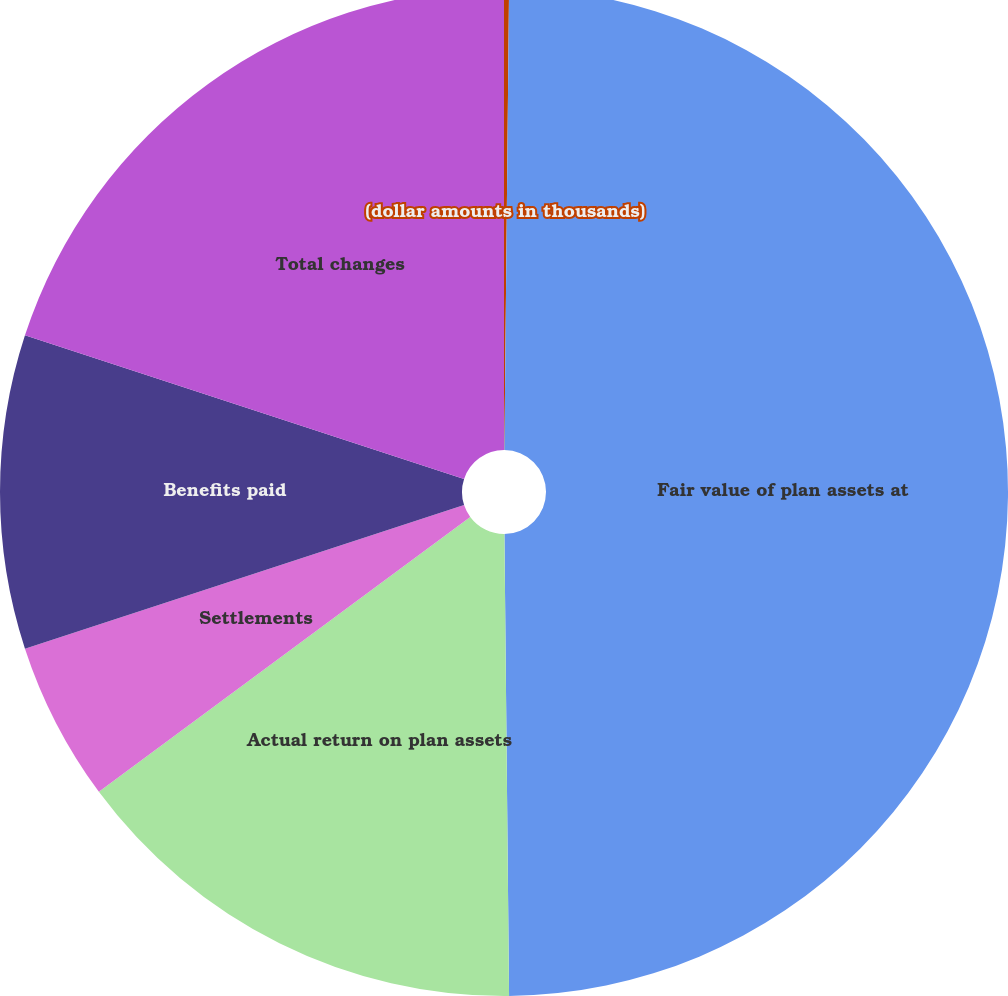Convert chart to OTSL. <chart><loc_0><loc_0><loc_500><loc_500><pie_chart><fcel>(dollar amounts in thousands)<fcel>Fair value of plan assets at<fcel>Actual return on plan assets<fcel>Settlements<fcel>Benefits paid<fcel>Total changes<nl><fcel>0.16%<fcel>49.68%<fcel>15.02%<fcel>5.11%<fcel>10.06%<fcel>19.97%<nl></chart> 